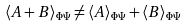Convert formula to latex. <formula><loc_0><loc_0><loc_500><loc_500>\langle A + B \rangle _ { \Phi \Psi } \neq \langle A \rangle _ { \Phi \Psi } + \langle B \rangle _ { \Phi \Psi }</formula> 